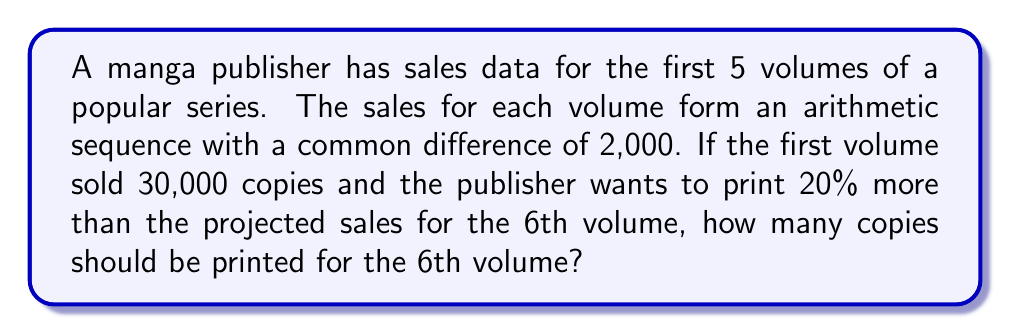Solve this math problem. Let's approach this step-by-step:

1) First, we need to identify the arithmetic sequence:
   $a_1 = 30,000$ (first term)
   $d = 2,000$ (common difference)

2) The general term of an arithmetic sequence is given by:
   $a_n = a_1 + (n-1)d$

3) We need to find $a_6$ (the 6th term):
   $a_6 = 30,000 + (6-1)2,000$
   $a_6 = 30,000 + 5(2,000)$
   $a_6 = 30,000 + 10,000 = 40,000$

4) The publisher wants to print 20% more than the projected sales:
   $\text{Print run} = a_6 + 20\% \text{ of } a_6$
   $\text{Print run} = 40,000 + 0.2(40,000)$
   $\text{Print run} = 40,000 + 8,000 = 48,000$

Therefore, the optimal print run for the 6th volume is 48,000 copies.
Answer: 48,000 copies 